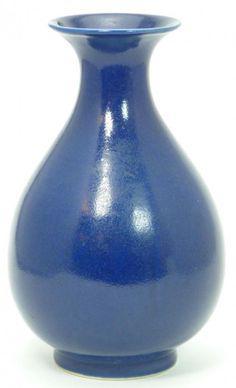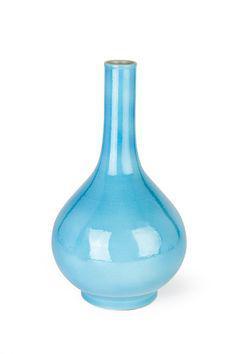The first image is the image on the left, the second image is the image on the right. Assess this claim about the two images: "There are at least 5 glass jars.". Correct or not? Answer yes or no. No. The first image is the image on the left, the second image is the image on the right. For the images displayed, is the sentence "The vases are made of repurposed bottles." factually correct? Answer yes or no. No. 